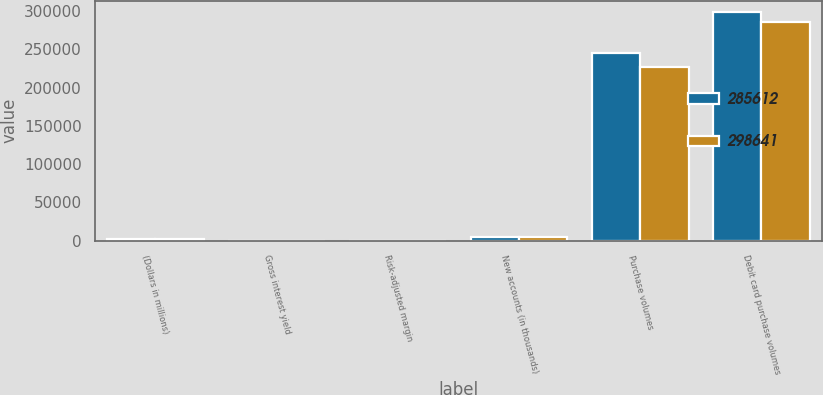Convert chart. <chart><loc_0><loc_0><loc_500><loc_500><stacked_bar_chart><ecel><fcel>(Dollars in millions)<fcel>Gross interest yield<fcel>Risk-adjusted margin<fcel>New accounts (in thousands)<fcel>Purchase volumes<fcel>Debit card purchase volumes<nl><fcel>285612<fcel>2017<fcel>9.65<fcel>8.67<fcel>4939<fcel>244753<fcel>298641<nl><fcel>298641<fcel>2016<fcel>9.29<fcel>9.04<fcel>4979<fcel>226432<fcel>285612<nl></chart> 